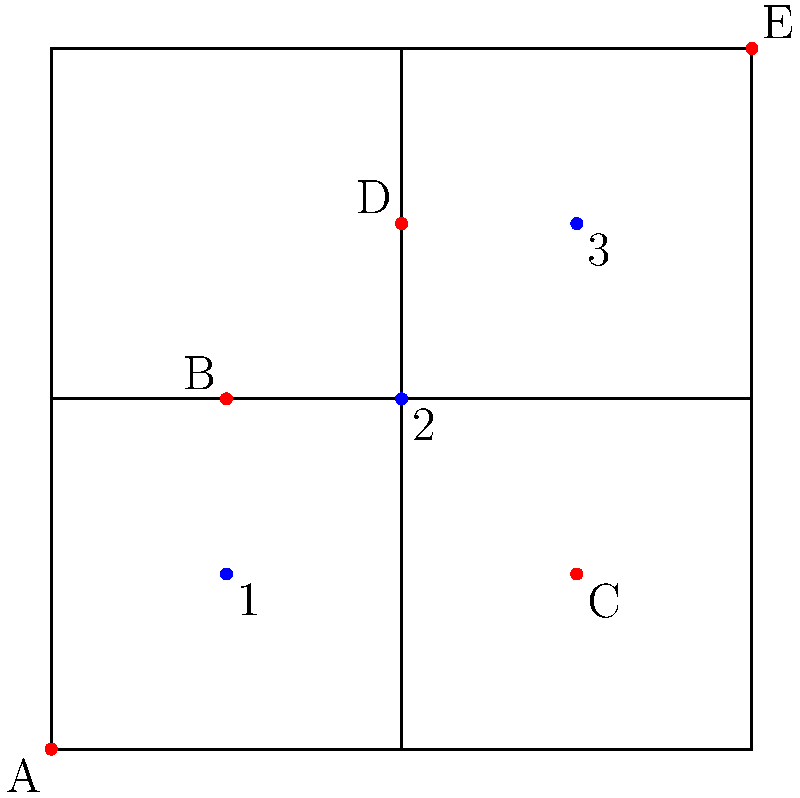As a caring dog walker, you need to plan the most efficient route to walk dogs from houses A, C, and E. Given that each block is 100 meters long, what is the minimum distance (in meters) you need to walk to visit all three houses and return to your starting point at house A, assuming you can only walk along the streets? To solve this problem, we need to find the shortest path that visits houses A, C, and E, and returns to A. Let's break it down step-by-step:

1. Identify the coordinates:
   House A: (0,0)
   House C: (3,1)
   House E: (4,4)

2. Calculate the distances between houses:
   A to C: 3 blocks east + 1 block north = 400m
   C to E: 1 block east + 3 blocks north = 400m
   E to A: 4 blocks west + 4 blocks south = 800m

3. Consider alternative routes:
   A to E: 4 blocks east + 4 blocks north = 800m
   E to C: 1 block west + 3 blocks south = 400m
   C to A: 3 blocks west + 1 block south = 400m

4. Compare the two possible routes:
   Route 1: A → C → E → A = 400m + 400m + 800m = 1600m
   Route 2: A → E → C → A = 800m + 400m + 400m = 1600m

Both routes have the same total distance of 1600 meters.

Therefore, the minimum distance to visit all three houses and return to the starting point is 1600 meters.
Answer: 1600 meters 